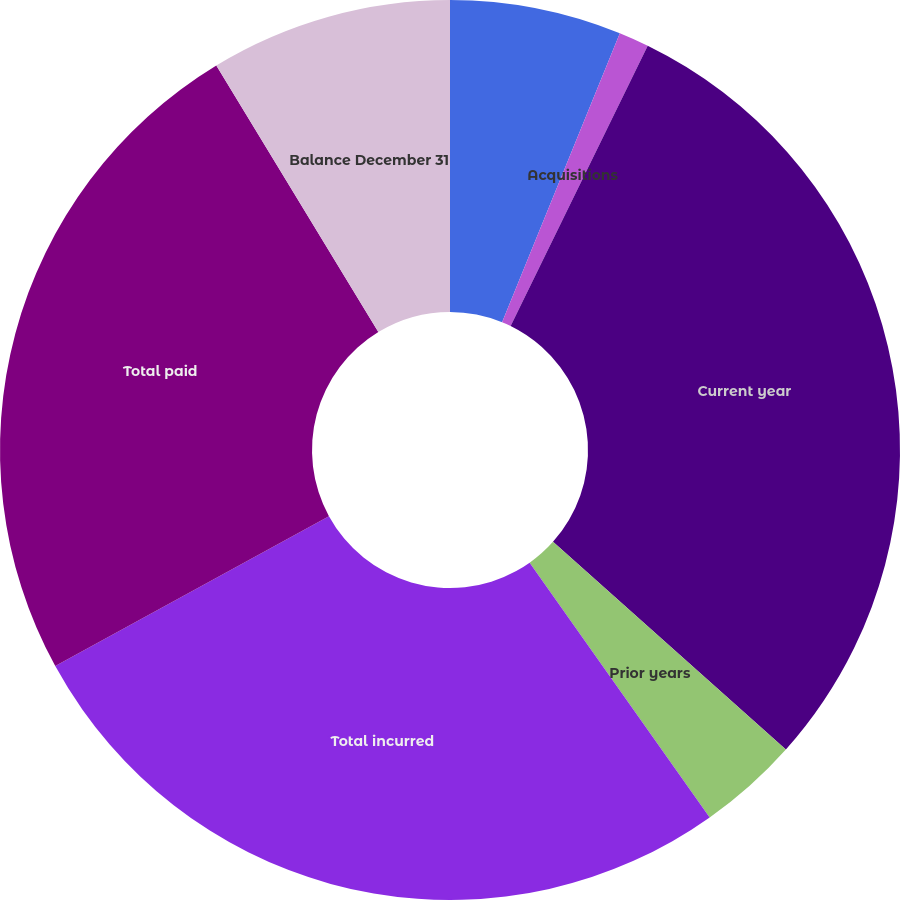<chart> <loc_0><loc_0><loc_500><loc_500><pie_chart><fcel>Balance January 1<fcel>Acquisitions<fcel>Current year<fcel>Prior years<fcel>Total incurred<fcel>Total paid<fcel>Balance December 31<nl><fcel>6.16%<fcel>1.08%<fcel>29.35%<fcel>3.62%<fcel>26.82%<fcel>24.28%<fcel>8.69%<nl></chart> 